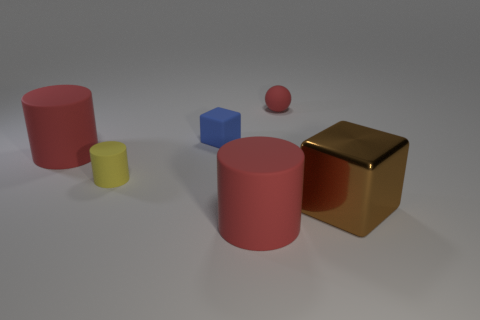Subtract all blue blocks. Subtract all yellow cylinders. How many blocks are left? 1 Add 2 cubes. How many objects exist? 8 Subtract all balls. How many objects are left? 5 Add 5 brown shiny cubes. How many brown shiny cubes exist? 6 Subtract 0 green cylinders. How many objects are left? 6 Subtract all yellow matte things. Subtract all small red rubber spheres. How many objects are left? 4 Add 1 yellow cylinders. How many yellow cylinders are left? 2 